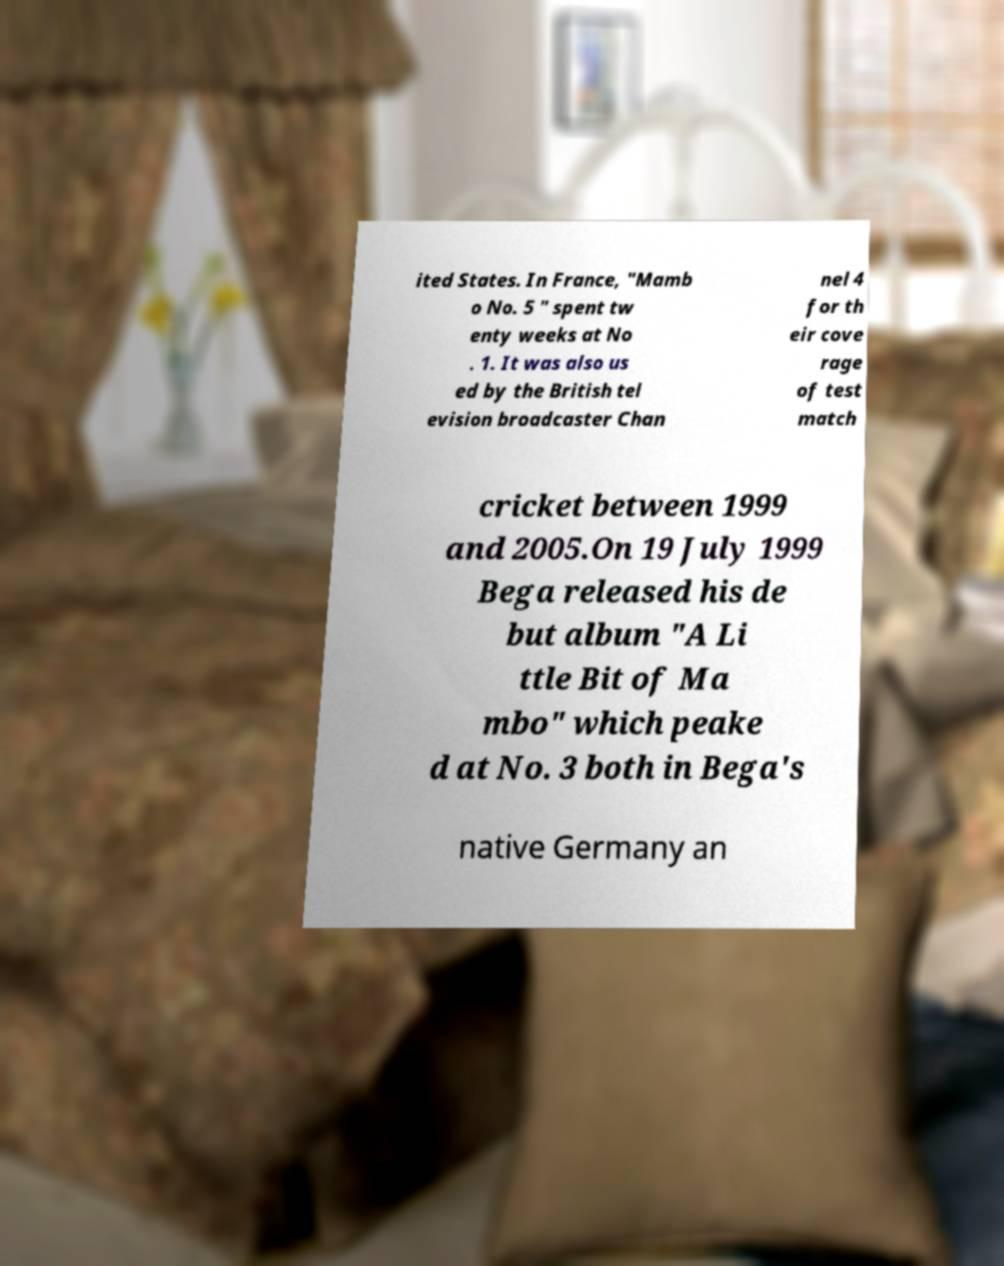Could you assist in decoding the text presented in this image and type it out clearly? ited States. In France, "Mamb o No. 5 " spent tw enty weeks at No . 1. It was also us ed by the British tel evision broadcaster Chan nel 4 for th eir cove rage of test match cricket between 1999 and 2005.On 19 July 1999 Bega released his de but album "A Li ttle Bit of Ma mbo" which peake d at No. 3 both in Bega's native Germany an 